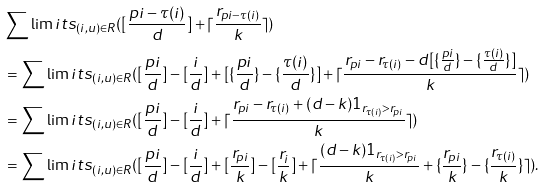Convert formula to latex. <formula><loc_0><loc_0><loc_500><loc_500>& \sum \lim i t s _ { ( i , u ) \in R } ( [ \frac { p i - \tau ( i ) } { d } ] + \lceil \frac { r _ { p i - \tau ( i ) } } { k } \rceil ) \\ & = \sum \lim i t s _ { ( i , u ) \in R } ( [ \frac { p i } { d } ] - [ \frac { i } { d } ] + [ \{ \frac { p i } { d } \} - \{ \frac { \tau ( i ) } { d } \} ] + \lceil \frac { r _ { p i } - r _ { \tau ( i ) } - d [ \{ \frac { p i } { d } \} - \{ \frac { \tau ( i ) } { d } \} ] } { k } \rceil ) \\ & = \sum \lim i t s _ { ( i , u ) \in R } ( [ \frac { p i } { d } ] - [ \frac { i } { d } ] + \lceil \frac { r _ { p i } - r _ { \tau ( i ) } + ( d - k ) 1 _ { r _ { \tau ( i ) } > r _ { p i } } } { k } \rceil ) \\ & = \sum \lim i t s _ { ( i , u ) \in R } ( [ \frac { p i } { d } ] - [ \frac { i } { d } ] + [ \frac { r _ { p i } } { k } ] - [ \frac { r _ { i } } { k } ] + \lceil \frac { ( d - k ) 1 _ { r _ { \tau ( i ) } > r _ { p i } } } { k } + \{ \frac { r _ { p i } } { k } \} - \{ \frac { r _ { \tau ( i ) } } { k } \} \rceil ) .</formula> 